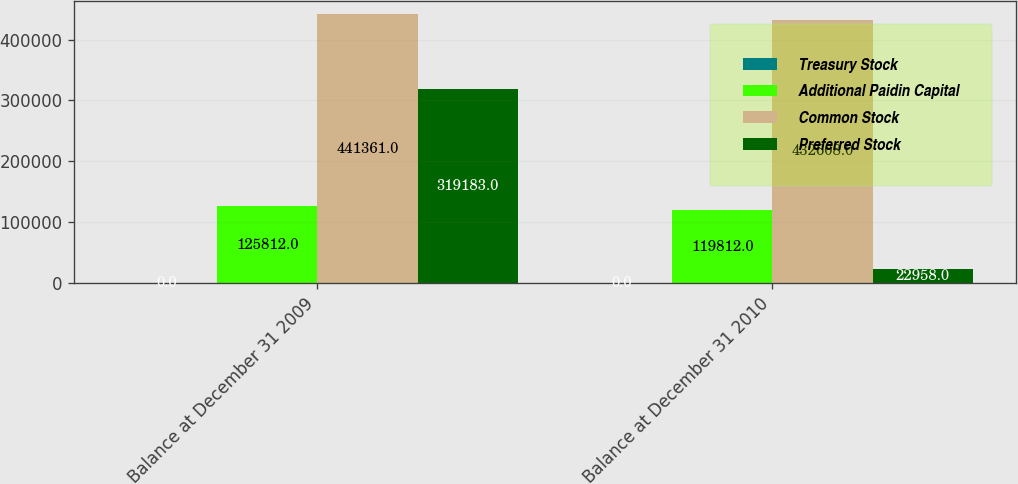<chart> <loc_0><loc_0><loc_500><loc_500><stacked_bar_chart><ecel><fcel>Balance at December 31 2009<fcel>Balance at December 31 2010<nl><fcel>Treasury Stock<fcel>0<fcel>0<nl><fcel>Additional Paidin Capital<fcel>125812<fcel>119812<nl><fcel>Common Stock<fcel>441361<fcel>432608<nl><fcel>Preferred Stock<fcel>319183<fcel>22958<nl></chart> 